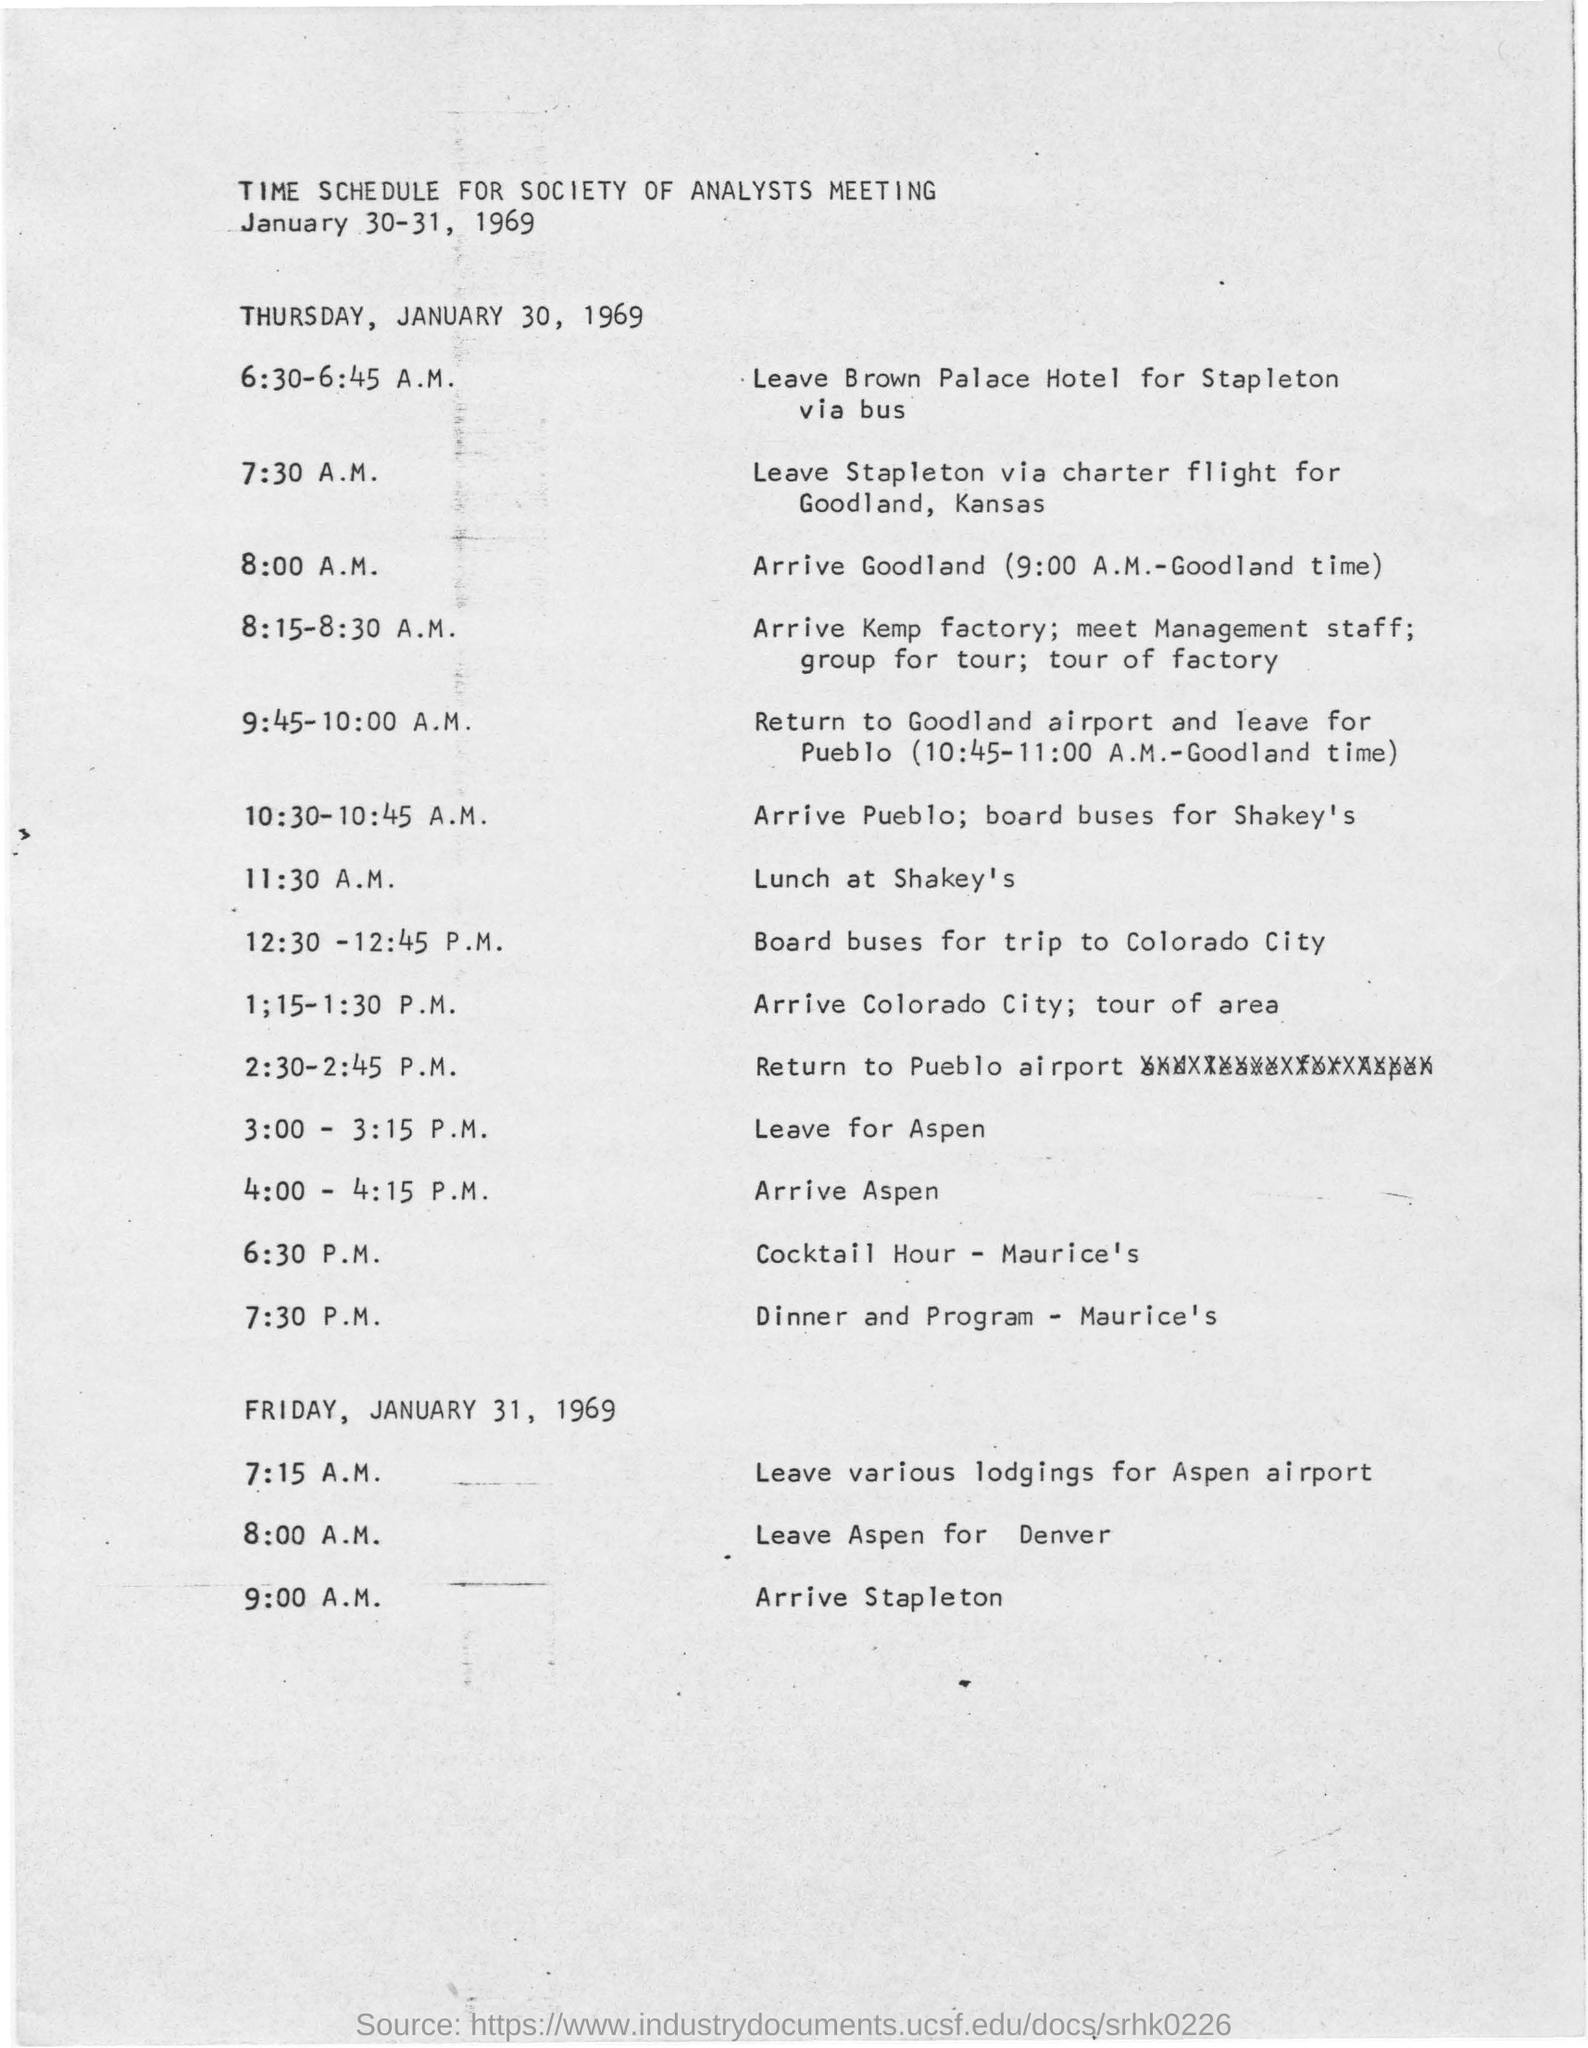Identify some key points in this picture. The Society of Analysts Meeting will be held on January 30-31, 1969. The lunch is scheduled to take place at Shakey's. 